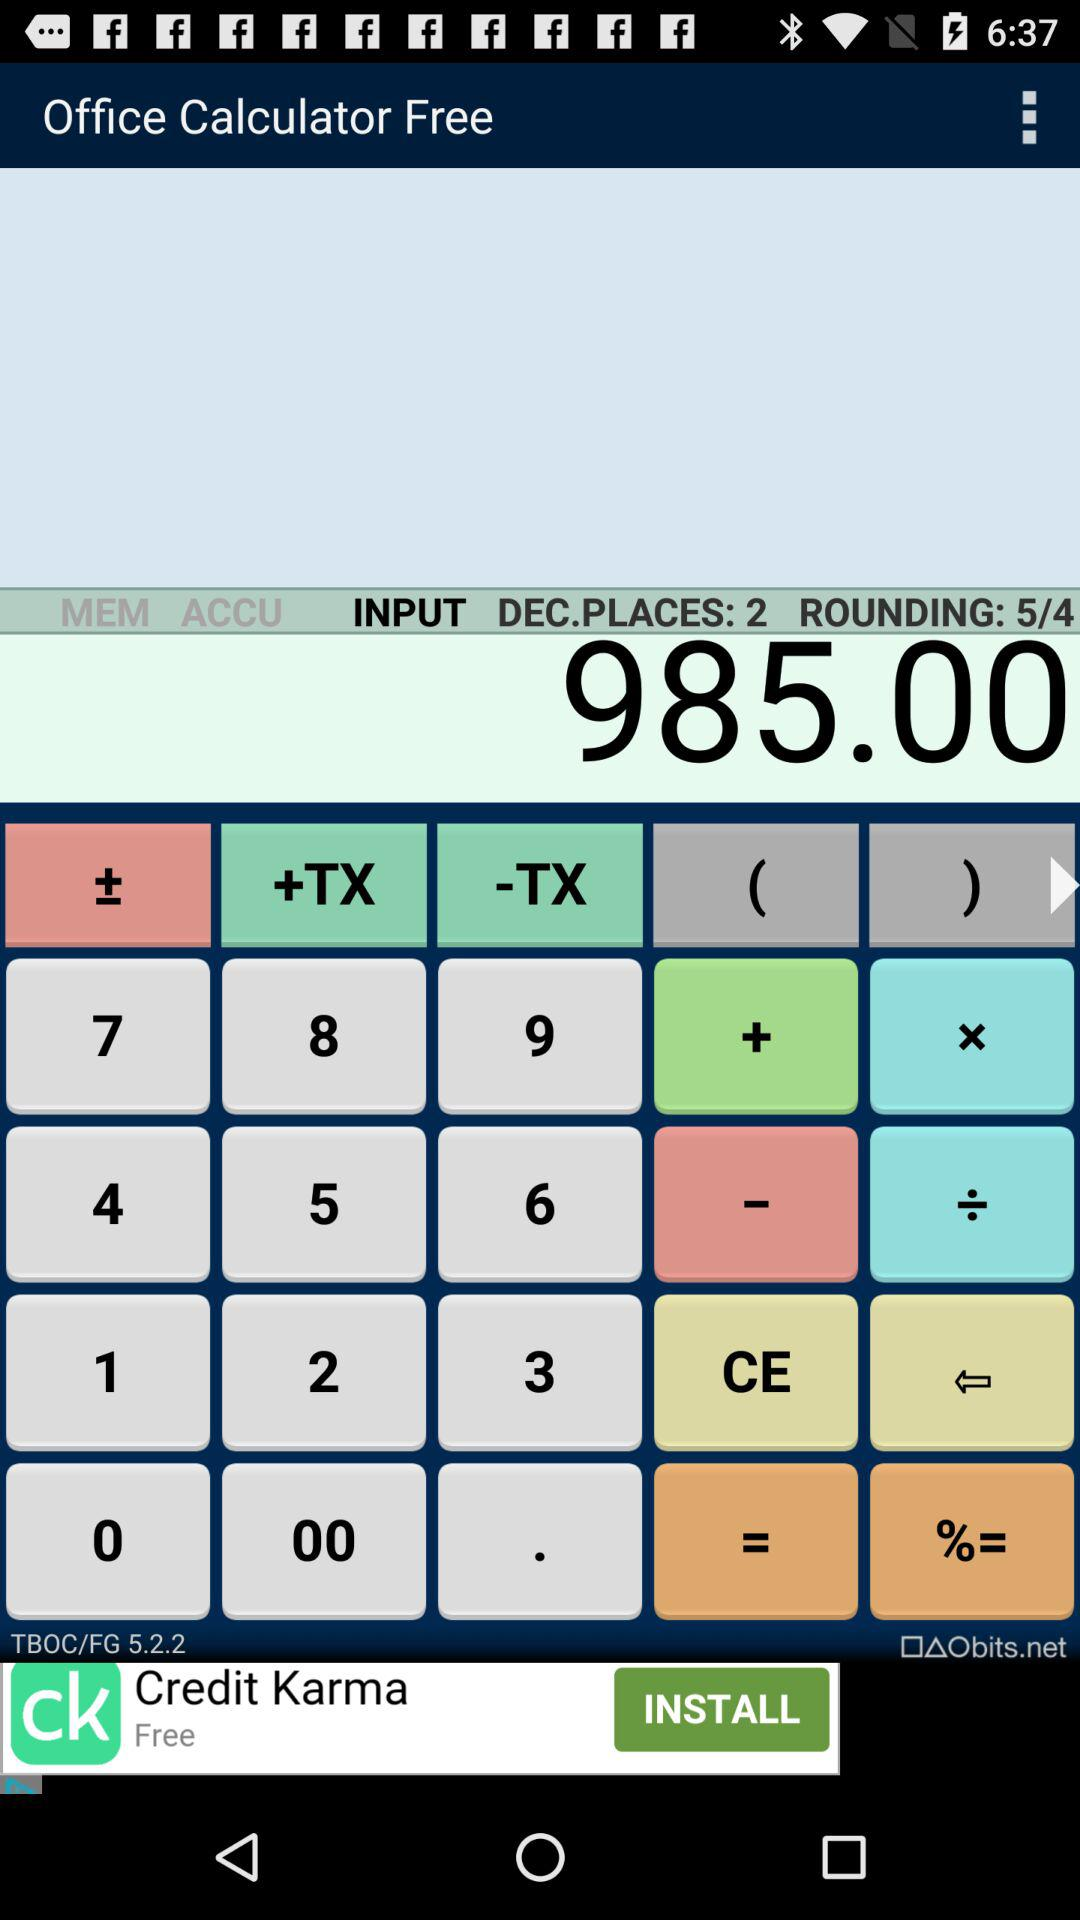Is the amount in USD?
When the provided information is insufficient, respond with <no answer>. <no answer> 